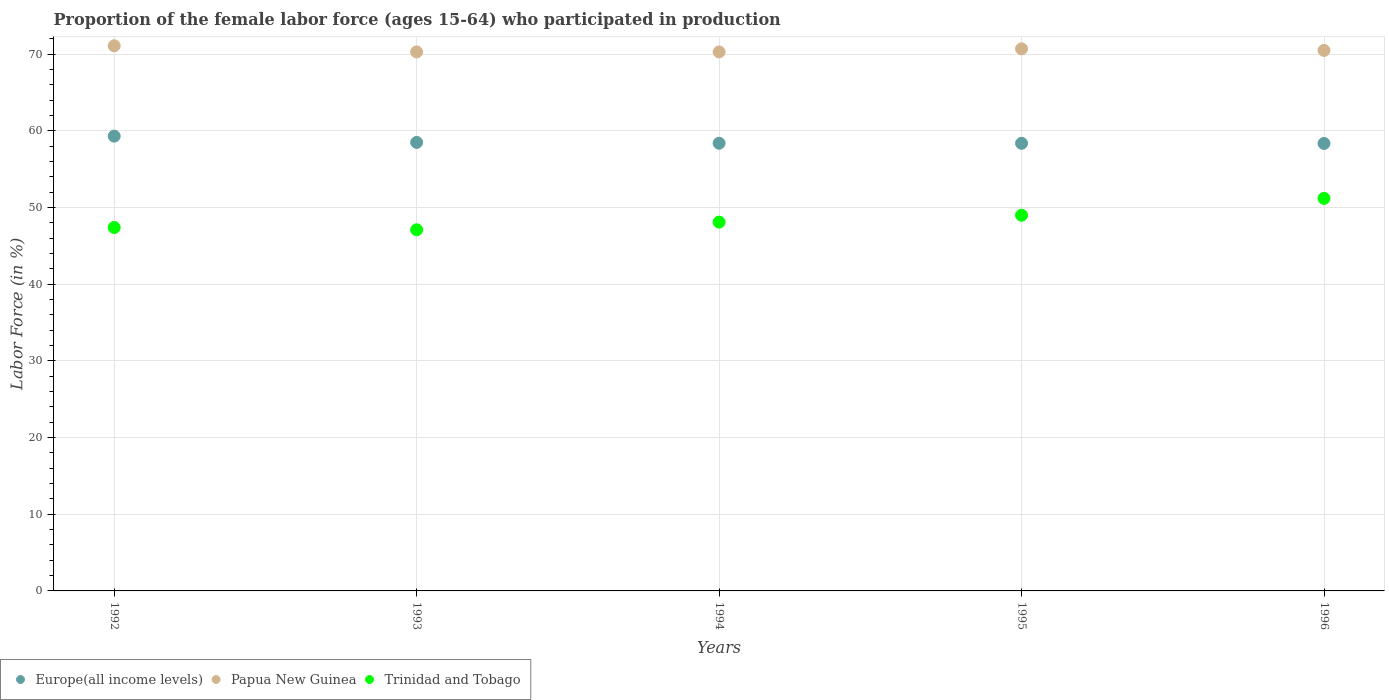How many different coloured dotlines are there?
Make the answer very short. 3. Is the number of dotlines equal to the number of legend labels?
Give a very brief answer. Yes. What is the proportion of the female labor force who participated in production in Trinidad and Tobago in 1993?
Provide a succinct answer. 47.1. Across all years, what is the maximum proportion of the female labor force who participated in production in Europe(all income levels)?
Provide a short and direct response. 59.32. Across all years, what is the minimum proportion of the female labor force who participated in production in Papua New Guinea?
Provide a succinct answer. 70.3. In which year was the proportion of the female labor force who participated in production in Europe(all income levels) maximum?
Your answer should be very brief. 1992. In which year was the proportion of the female labor force who participated in production in Trinidad and Tobago minimum?
Your answer should be compact. 1993. What is the total proportion of the female labor force who participated in production in Papua New Guinea in the graph?
Your answer should be compact. 352.9. What is the difference between the proportion of the female labor force who participated in production in Trinidad and Tobago in 1993 and that in 1995?
Offer a very short reply. -1.9. What is the difference between the proportion of the female labor force who participated in production in Papua New Guinea in 1993 and the proportion of the female labor force who participated in production in Europe(all income levels) in 1992?
Give a very brief answer. 10.98. What is the average proportion of the female labor force who participated in production in Trinidad and Tobago per year?
Your response must be concise. 48.56. In the year 1996, what is the difference between the proportion of the female labor force who participated in production in Trinidad and Tobago and proportion of the female labor force who participated in production in Europe(all income levels)?
Your answer should be very brief. -7.16. What is the ratio of the proportion of the female labor force who participated in production in Trinidad and Tobago in 1993 to that in 1996?
Your response must be concise. 0.92. What is the difference between the highest and the second highest proportion of the female labor force who participated in production in Trinidad and Tobago?
Make the answer very short. 2.2. What is the difference between the highest and the lowest proportion of the female labor force who participated in production in Europe(all income levels)?
Your answer should be very brief. 0.95. Does the proportion of the female labor force who participated in production in Europe(all income levels) monotonically increase over the years?
Give a very brief answer. No. Is the proportion of the female labor force who participated in production in Europe(all income levels) strictly greater than the proportion of the female labor force who participated in production in Trinidad and Tobago over the years?
Your answer should be very brief. Yes. Are the values on the major ticks of Y-axis written in scientific E-notation?
Offer a terse response. No. Does the graph contain any zero values?
Make the answer very short. No. Does the graph contain grids?
Ensure brevity in your answer.  Yes. How many legend labels are there?
Provide a succinct answer. 3. How are the legend labels stacked?
Give a very brief answer. Horizontal. What is the title of the graph?
Give a very brief answer. Proportion of the female labor force (ages 15-64) who participated in production. What is the label or title of the X-axis?
Make the answer very short. Years. What is the Labor Force (in %) in Europe(all income levels) in 1992?
Provide a succinct answer. 59.32. What is the Labor Force (in %) in Papua New Guinea in 1992?
Give a very brief answer. 71.1. What is the Labor Force (in %) of Trinidad and Tobago in 1992?
Provide a short and direct response. 47.4. What is the Labor Force (in %) of Europe(all income levels) in 1993?
Provide a short and direct response. 58.5. What is the Labor Force (in %) in Papua New Guinea in 1993?
Offer a terse response. 70.3. What is the Labor Force (in %) in Trinidad and Tobago in 1993?
Your answer should be compact. 47.1. What is the Labor Force (in %) of Europe(all income levels) in 1994?
Give a very brief answer. 58.39. What is the Labor Force (in %) of Papua New Guinea in 1994?
Your answer should be very brief. 70.3. What is the Labor Force (in %) in Trinidad and Tobago in 1994?
Give a very brief answer. 48.1. What is the Labor Force (in %) of Europe(all income levels) in 1995?
Offer a very short reply. 58.38. What is the Labor Force (in %) in Papua New Guinea in 1995?
Ensure brevity in your answer.  70.7. What is the Labor Force (in %) in Trinidad and Tobago in 1995?
Offer a very short reply. 49. What is the Labor Force (in %) in Europe(all income levels) in 1996?
Your response must be concise. 58.36. What is the Labor Force (in %) in Papua New Guinea in 1996?
Provide a succinct answer. 70.5. What is the Labor Force (in %) in Trinidad and Tobago in 1996?
Your answer should be very brief. 51.2. Across all years, what is the maximum Labor Force (in %) of Europe(all income levels)?
Ensure brevity in your answer.  59.32. Across all years, what is the maximum Labor Force (in %) of Papua New Guinea?
Provide a short and direct response. 71.1. Across all years, what is the maximum Labor Force (in %) of Trinidad and Tobago?
Your response must be concise. 51.2. Across all years, what is the minimum Labor Force (in %) in Europe(all income levels)?
Ensure brevity in your answer.  58.36. Across all years, what is the minimum Labor Force (in %) in Papua New Guinea?
Offer a terse response. 70.3. Across all years, what is the minimum Labor Force (in %) in Trinidad and Tobago?
Make the answer very short. 47.1. What is the total Labor Force (in %) of Europe(all income levels) in the graph?
Provide a short and direct response. 292.94. What is the total Labor Force (in %) of Papua New Guinea in the graph?
Provide a short and direct response. 352.9. What is the total Labor Force (in %) of Trinidad and Tobago in the graph?
Provide a short and direct response. 242.8. What is the difference between the Labor Force (in %) in Europe(all income levels) in 1992 and that in 1993?
Make the answer very short. 0.82. What is the difference between the Labor Force (in %) in Papua New Guinea in 1992 and that in 1993?
Offer a very short reply. 0.8. What is the difference between the Labor Force (in %) in Europe(all income levels) in 1992 and that in 1994?
Ensure brevity in your answer.  0.93. What is the difference between the Labor Force (in %) in Papua New Guinea in 1992 and that in 1994?
Ensure brevity in your answer.  0.8. What is the difference between the Labor Force (in %) in Europe(all income levels) in 1992 and that in 1995?
Keep it short and to the point. 0.93. What is the difference between the Labor Force (in %) of Papua New Guinea in 1992 and that in 1995?
Provide a succinct answer. 0.4. What is the difference between the Labor Force (in %) in Europe(all income levels) in 1992 and that in 1996?
Make the answer very short. 0.95. What is the difference between the Labor Force (in %) of Trinidad and Tobago in 1992 and that in 1996?
Provide a short and direct response. -3.8. What is the difference between the Labor Force (in %) of Europe(all income levels) in 1993 and that in 1994?
Keep it short and to the point. 0.11. What is the difference between the Labor Force (in %) of Europe(all income levels) in 1993 and that in 1995?
Keep it short and to the point. 0.12. What is the difference between the Labor Force (in %) of Papua New Guinea in 1993 and that in 1995?
Keep it short and to the point. -0.4. What is the difference between the Labor Force (in %) of Trinidad and Tobago in 1993 and that in 1995?
Provide a short and direct response. -1.9. What is the difference between the Labor Force (in %) in Europe(all income levels) in 1993 and that in 1996?
Provide a succinct answer. 0.13. What is the difference between the Labor Force (in %) in Papua New Guinea in 1993 and that in 1996?
Your answer should be very brief. -0.2. What is the difference between the Labor Force (in %) of Trinidad and Tobago in 1993 and that in 1996?
Provide a succinct answer. -4.1. What is the difference between the Labor Force (in %) in Europe(all income levels) in 1994 and that in 1995?
Keep it short and to the point. 0.01. What is the difference between the Labor Force (in %) of Trinidad and Tobago in 1994 and that in 1995?
Ensure brevity in your answer.  -0.9. What is the difference between the Labor Force (in %) in Europe(all income levels) in 1994 and that in 1996?
Give a very brief answer. 0.03. What is the difference between the Labor Force (in %) of Europe(all income levels) in 1995 and that in 1996?
Make the answer very short. 0.02. What is the difference between the Labor Force (in %) in Trinidad and Tobago in 1995 and that in 1996?
Give a very brief answer. -2.2. What is the difference between the Labor Force (in %) in Europe(all income levels) in 1992 and the Labor Force (in %) in Papua New Guinea in 1993?
Your answer should be compact. -10.98. What is the difference between the Labor Force (in %) in Europe(all income levels) in 1992 and the Labor Force (in %) in Trinidad and Tobago in 1993?
Make the answer very short. 12.22. What is the difference between the Labor Force (in %) in Papua New Guinea in 1992 and the Labor Force (in %) in Trinidad and Tobago in 1993?
Offer a very short reply. 24. What is the difference between the Labor Force (in %) in Europe(all income levels) in 1992 and the Labor Force (in %) in Papua New Guinea in 1994?
Your answer should be compact. -10.98. What is the difference between the Labor Force (in %) in Europe(all income levels) in 1992 and the Labor Force (in %) in Trinidad and Tobago in 1994?
Give a very brief answer. 11.22. What is the difference between the Labor Force (in %) of Papua New Guinea in 1992 and the Labor Force (in %) of Trinidad and Tobago in 1994?
Your answer should be compact. 23. What is the difference between the Labor Force (in %) of Europe(all income levels) in 1992 and the Labor Force (in %) of Papua New Guinea in 1995?
Offer a very short reply. -11.38. What is the difference between the Labor Force (in %) in Europe(all income levels) in 1992 and the Labor Force (in %) in Trinidad and Tobago in 1995?
Your response must be concise. 10.32. What is the difference between the Labor Force (in %) in Papua New Guinea in 1992 and the Labor Force (in %) in Trinidad and Tobago in 1995?
Make the answer very short. 22.1. What is the difference between the Labor Force (in %) in Europe(all income levels) in 1992 and the Labor Force (in %) in Papua New Guinea in 1996?
Make the answer very short. -11.18. What is the difference between the Labor Force (in %) in Europe(all income levels) in 1992 and the Labor Force (in %) in Trinidad and Tobago in 1996?
Give a very brief answer. 8.12. What is the difference between the Labor Force (in %) of Europe(all income levels) in 1993 and the Labor Force (in %) of Papua New Guinea in 1994?
Your answer should be very brief. -11.8. What is the difference between the Labor Force (in %) of Europe(all income levels) in 1993 and the Labor Force (in %) of Trinidad and Tobago in 1994?
Your answer should be compact. 10.4. What is the difference between the Labor Force (in %) in Europe(all income levels) in 1993 and the Labor Force (in %) in Papua New Guinea in 1995?
Provide a short and direct response. -12.2. What is the difference between the Labor Force (in %) in Europe(all income levels) in 1993 and the Labor Force (in %) in Trinidad and Tobago in 1995?
Make the answer very short. 9.5. What is the difference between the Labor Force (in %) in Papua New Guinea in 1993 and the Labor Force (in %) in Trinidad and Tobago in 1995?
Provide a short and direct response. 21.3. What is the difference between the Labor Force (in %) of Europe(all income levels) in 1993 and the Labor Force (in %) of Papua New Guinea in 1996?
Ensure brevity in your answer.  -12. What is the difference between the Labor Force (in %) of Europe(all income levels) in 1993 and the Labor Force (in %) of Trinidad and Tobago in 1996?
Make the answer very short. 7.3. What is the difference between the Labor Force (in %) of Europe(all income levels) in 1994 and the Labor Force (in %) of Papua New Guinea in 1995?
Make the answer very short. -12.31. What is the difference between the Labor Force (in %) in Europe(all income levels) in 1994 and the Labor Force (in %) in Trinidad and Tobago in 1995?
Keep it short and to the point. 9.39. What is the difference between the Labor Force (in %) in Papua New Guinea in 1994 and the Labor Force (in %) in Trinidad and Tobago in 1995?
Make the answer very short. 21.3. What is the difference between the Labor Force (in %) in Europe(all income levels) in 1994 and the Labor Force (in %) in Papua New Guinea in 1996?
Provide a short and direct response. -12.11. What is the difference between the Labor Force (in %) of Europe(all income levels) in 1994 and the Labor Force (in %) of Trinidad and Tobago in 1996?
Provide a succinct answer. 7.19. What is the difference between the Labor Force (in %) of Papua New Guinea in 1994 and the Labor Force (in %) of Trinidad and Tobago in 1996?
Offer a terse response. 19.1. What is the difference between the Labor Force (in %) of Europe(all income levels) in 1995 and the Labor Force (in %) of Papua New Guinea in 1996?
Offer a terse response. -12.12. What is the difference between the Labor Force (in %) in Europe(all income levels) in 1995 and the Labor Force (in %) in Trinidad and Tobago in 1996?
Your response must be concise. 7.18. What is the difference between the Labor Force (in %) in Papua New Guinea in 1995 and the Labor Force (in %) in Trinidad and Tobago in 1996?
Your response must be concise. 19.5. What is the average Labor Force (in %) of Europe(all income levels) per year?
Offer a very short reply. 58.59. What is the average Labor Force (in %) in Papua New Guinea per year?
Your response must be concise. 70.58. What is the average Labor Force (in %) in Trinidad and Tobago per year?
Provide a succinct answer. 48.56. In the year 1992, what is the difference between the Labor Force (in %) of Europe(all income levels) and Labor Force (in %) of Papua New Guinea?
Offer a very short reply. -11.78. In the year 1992, what is the difference between the Labor Force (in %) in Europe(all income levels) and Labor Force (in %) in Trinidad and Tobago?
Your answer should be compact. 11.92. In the year 1992, what is the difference between the Labor Force (in %) of Papua New Guinea and Labor Force (in %) of Trinidad and Tobago?
Your response must be concise. 23.7. In the year 1993, what is the difference between the Labor Force (in %) of Europe(all income levels) and Labor Force (in %) of Papua New Guinea?
Give a very brief answer. -11.8. In the year 1993, what is the difference between the Labor Force (in %) of Europe(all income levels) and Labor Force (in %) of Trinidad and Tobago?
Ensure brevity in your answer.  11.4. In the year 1993, what is the difference between the Labor Force (in %) in Papua New Guinea and Labor Force (in %) in Trinidad and Tobago?
Your answer should be very brief. 23.2. In the year 1994, what is the difference between the Labor Force (in %) in Europe(all income levels) and Labor Force (in %) in Papua New Guinea?
Give a very brief answer. -11.91. In the year 1994, what is the difference between the Labor Force (in %) of Europe(all income levels) and Labor Force (in %) of Trinidad and Tobago?
Give a very brief answer. 10.29. In the year 1995, what is the difference between the Labor Force (in %) of Europe(all income levels) and Labor Force (in %) of Papua New Guinea?
Your answer should be compact. -12.32. In the year 1995, what is the difference between the Labor Force (in %) of Europe(all income levels) and Labor Force (in %) of Trinidad and Tobago?
Offer a very short reply. 9.38. In the year 1995, what is the difference between the Labor Force (in %) in Papua New Guinea and Labor Force (in %) in Trinidad and Tobago?
Your answer should be very brief. 21.7. In the year 1996, what is the difference between the Labor Force (in %) of Europe(all income levels) and Labor Force (in %) of Papua New Guinea?
Provide a succinct answer. -12.14. In the year 1996, what is the difference between the Labor Force (in %) in Europe(all income levels) and Labor Force (in %) in Trinidad and Tobago?
Keep it short and to the point. 7.16. In the year 1996, what is the difference between the Labor Force (in %) in Papua New Guinea and Labor Force (in %) in Trinidad and Tobago?
Provide a succinct answer. 19.3. What is the ratio of the Labor Force (in %) in Papua New Guinea in 1992 to that in 1993?
Your response must be concise. 1.01. What is the ratio of the Labor Force (in %) of Trinidad and Tobago in 1992 to that in 1993?
Offer a very short reply. 1.01. What is the ratio of the Labor Force (in %) of Europe(all income levels) in 1992 to that in 1994?
Ensure brevity in your answer.  1.02. What is the ratio of the Labor Force (in %) in Papua New Guinea in 1992 to that in 1994?
Offer a very short reply. 1.01. What is the ratio of the Labor Force (in %) of Trinidad and Tobago in 1992 to that in 1994?
Give a very brief answer. 0.99. What is the ratio of the Labor Force (in %) of Trinidad and Tobago in 1992 to that in 1995?
Provide a succinct answer. 0.97. What is the ratio of the Labor Force (in %) of Europe(all income levels) in 1992 to that in 1996?
Give a very brief answer. 1.02. What is the ratio of the Labor Force (in %) of Papua New Guinea in 1992 to that in 1996?
Offer a very short reply. 1.01. What is the ratio of the Labor Force (in %) in Trinidad and Tobago in 1992 to that in 1996?
Your answer should be very brief. 0.93. What is the ratio of the Labor Force (in %) in Europe(all income levels) in 1993 to that in 1994?
Provide a short and direct response. 1. What is the ratio of the Labor Force (in %) of Trinidad and Tobago in 1993 to that in 1994?
Offer a very short reply. 0.98. What is the ratio of the Labor Force (in %) in Trinidad and Tobago in 1993 to that in 1995?
Give a very brief answer. 0.96. What is the ratio of the Labor Force (in %) in Trinidad and Tobago in 1993 to that in 1996?
Make the answer very short. 0.92. What is the ratio of the Labor Force (in %) in Europe(all income levels) in 1994 to that in 1995?
Provide a succinct answer. 1. What is the ratio of the Labor Force (in %) in Papua New Guinea in 1994 to that in 1995?
Your answer should be very brief. 0.99. What is the ratio of the Labor Force (in %) of Trinidad and Tobago in 1994 to that in 1995?
Keep it short and to the point. 0.98. What is the ratio of the Labor Force (in %) of Trinidad and Tobago in 1994 to that in 1996?
Offer a very short reply. 0.94. What is the ratio of the Labor Force (in %) of Papua New Guinea in 1995 to that in 1996?
Provide a succinct answer. 1. What is the ratio of the Labor Force (in %) of Trinidad and Tobago in 1995 to that in 1996?
Make the answer very short. 0.96. What is the difference between the highest and the second highest Labor Force (in %) of Europe(all income levels)?
Your answer should be compact. 0.82. What is the difference between the highest and the second highest Labor Force (in %) in Papua New Guinea?
Ensure brevity in your answer.  0.4. What is the difference between the highest and the second highest Labor Force (in %) of Trinidad and Tobago?
Give a very brief answer. 2.2. What is the difference between the highest and the lowest Labor Force (in %) of Europe(all income levels)?
Give a very brief answer. 0.95. What is the difference between the highest and the lowest Labor Force (in %) of Trinidad and Tobago?
Make the answer very short. 4.1. 